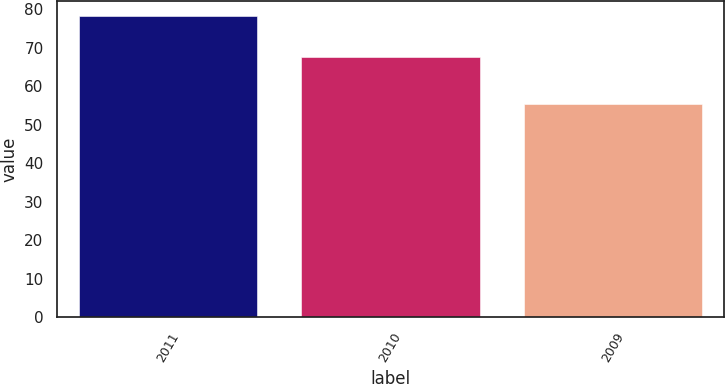<chart> <loc_0><loc_0><loc_500><loc_500><bar_chart><fcel>2011<fcel>2010<fcel>2009<nl><fcel>78.1<fcel>67.6<fcel>55.5<nl></chart> 